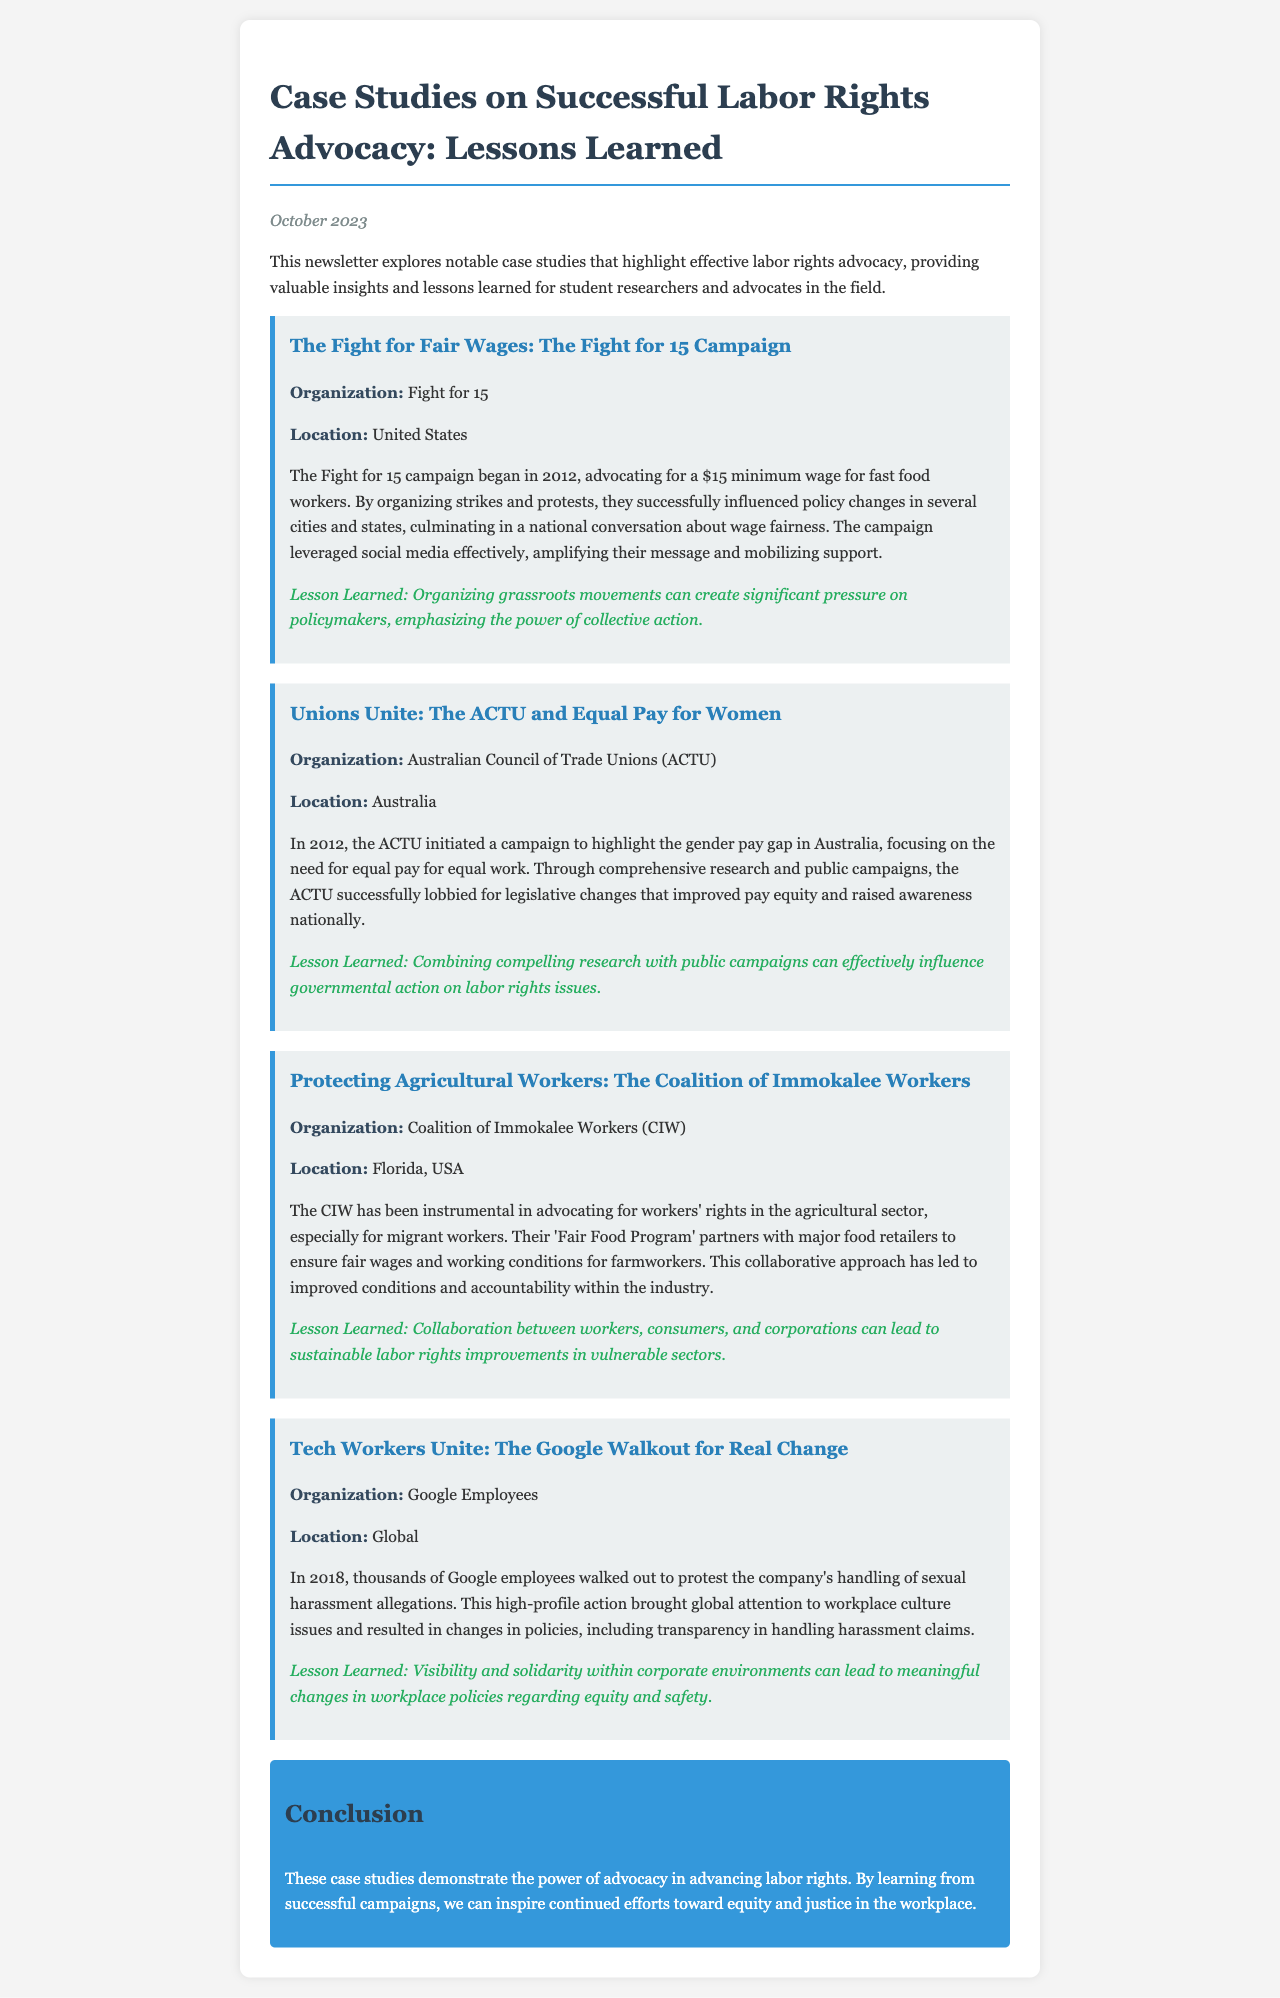What is the title of the newsletter? The title is stated at the beginning of the document, summarizing its focus on labor rights advocacy.
Answer: Case Studies on Successful Labor Rights Advocacy: Lessons Learned What organization initiated the Fight for 15 campaign? The document specifically lists this organization under the case study heading, indicating their role in the campaign.
Answer: Fight for 15 In which year did the ACTU start their campaign for equal pay? The year of the ACTU's campaign is mentioned explicitly in the case study details, providing an important chronological aspect of the advocacy.
Answer: 2012 What lesson was learned from the Coalition of Immokalee Workers? The lesson is highlighted in the case study, summarizing key findings from their advocacy efforts in labor rights.
Answer: Collaboration between workers, consumers, and corporations can lead to sustainable labor rights improvements in vulnerable sectors How many workers walked out during the Google protest? While the exact number may not be directly stated, the document emphasizes that thousands of employees participated in the protest action.
Answer: Thousands What is the focus of the Fair Food Program? This program's focus is detailed in the case study outlining its objectives for agricultural workers' rights.
Answer: Fair wages and working conditions for farmworkers What is one key strategy used by the Fight for 15 campaign? The strategy is discussed in the campaign's case study, illustrating successful advocacy techniques used by the organization.
Answer: Organizing strikes and protests What does the conclusion emphasize about the power of advocacy? The conclusion synthesizes the main themes of the newsletter, encapsulating the overall message regarding labor rights advocacy.
Answer: The power of advocacy in advancing labor rights 